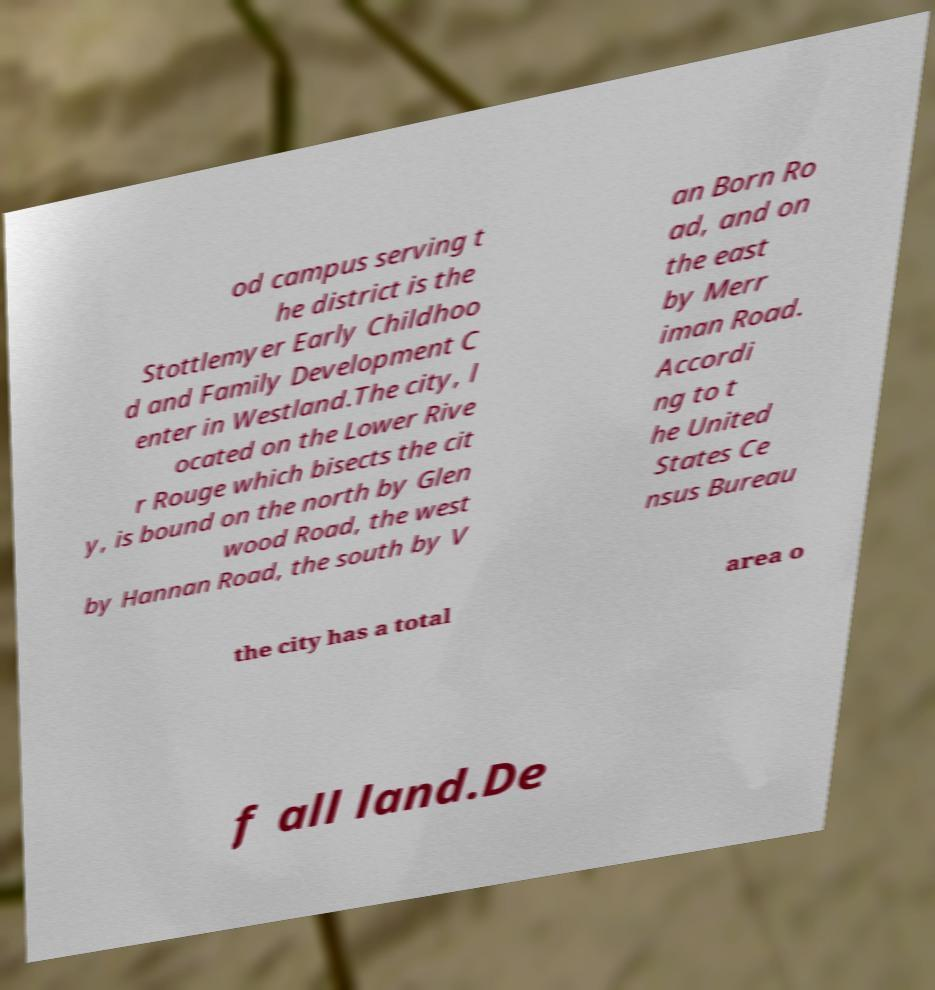What messages or text are displayed in this image? I need them in a readable, typed format. od campus serving t he district is the Stottlemyer Early Childhoo d and Family Development C enter in Westland.The city, l ocated on the Lower Rive r Rouge which bisects the cit y, is bound on the north by Glen wood Road, the west by Hannan Road, the south by V an Born Ro ad, and on the east by Merr iman Road. Accordi ng to t he United States Ce nsus Bureau the city has a total area o f all land.De 